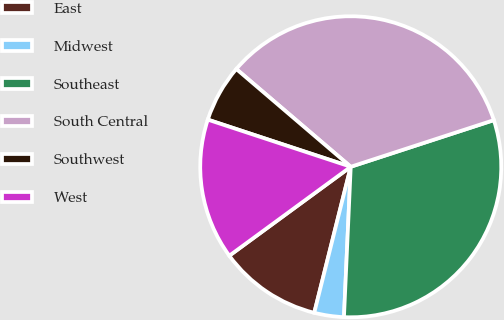Convert chart to OTSL. <chart><loc_0><loc_0><loc_500><loc_500><pie_chart><fcel>East<fcel>Midwest<fcel>Southeast<fcel>South Central<fcel>Southwest<fcel>West<nl><fcel>11.04%<fcel>3.18%<fcel>30.73%<fcel>33.73%<fcel>6.18%<fcel>15.13%<nl></chart> 